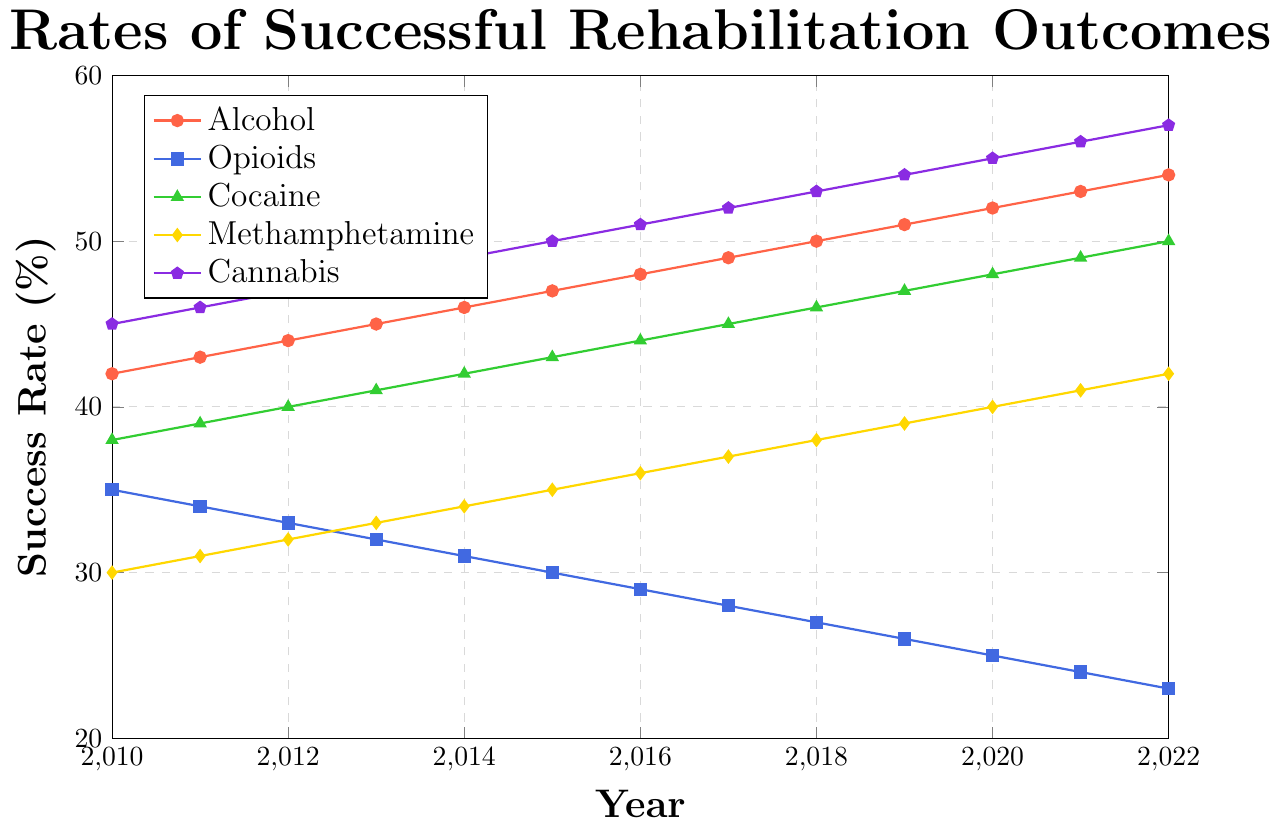How does the success rate for alcohol rehabilitation change from 2010 to 2022? To find the change in success rate for alcohol rehabilitation from 2010 to 2022, we subtract the 2010 success rate (42%) from the 2022 success rate (54%). Thus, 54% - 42% = 12%.
Answer: 12% Which addiction type had the highest success rate in 2022? Reviewing the chart, the line representing cannabis (colored purple) is the highest in 2022 with a success rate of 57%.
Answer: Cannabis Compare the trends of success rates for opioids and alcohol from 2010 to 2022. The success rate for alcohol steadily increases from 42% to 54%. In contrast, the success rate for opioids consistently decreases from 35% to 23% over the same period. Alcohol's line is ascending, while opioids' line is descending.
Answer: Alcohol increases, Opioids decrease What is the difference in the success rate for cocaine rehabilitation between 2010 and 2019? To find the difference in success rate for cocaine rehabilitation between 2010 and 2019, we subtract the 2010 success rate (38%) from the 2019 success rate (47%). Thus, 47% - 38% = 9%.
Answer: 9% Which addiction type has the steepest decline in success rates over time? By examining the slope of each line, opioids (colored blue) shows the steepest decline, dropping from 35% in 2010 to 23% in 2022.
Answer: Opioids What is the average success rate for methamphetamine rehabilitation from 2010 to 2022? The success rates for methamphetamine rehabilitation from 2010 to 2022 are: 30%, 31%, 32%, 33%, 34%, 35%, 36%, 37%, 38%, 39%, 40%, 41%, and 42%. Summing these, we get 468%. There are 13 years, so 468%/13 = 36%.
Answer: 36% How do the success rates for methamphetamine and cannabis compare in 2015? In 2015, the success rate for methamphetamine is 35%, and for cannabis it is 50%, indicating that the success rate for cannabis is significantly higher.
Answer: Cannabis is higher By how much did the success rate for cannabis increase from 2010 to 2020? To find the increase in success rate for cannabis from 2010 to 2020, we subtract the 2010 success rate (45%) from the 2020 success rate (55%). Thus, 55% - 45% = 10%.
Answer: 10% What color is used to represent the line for cocaine in the chart? The line for cocaine is represented by a green color.
Answer: Green 